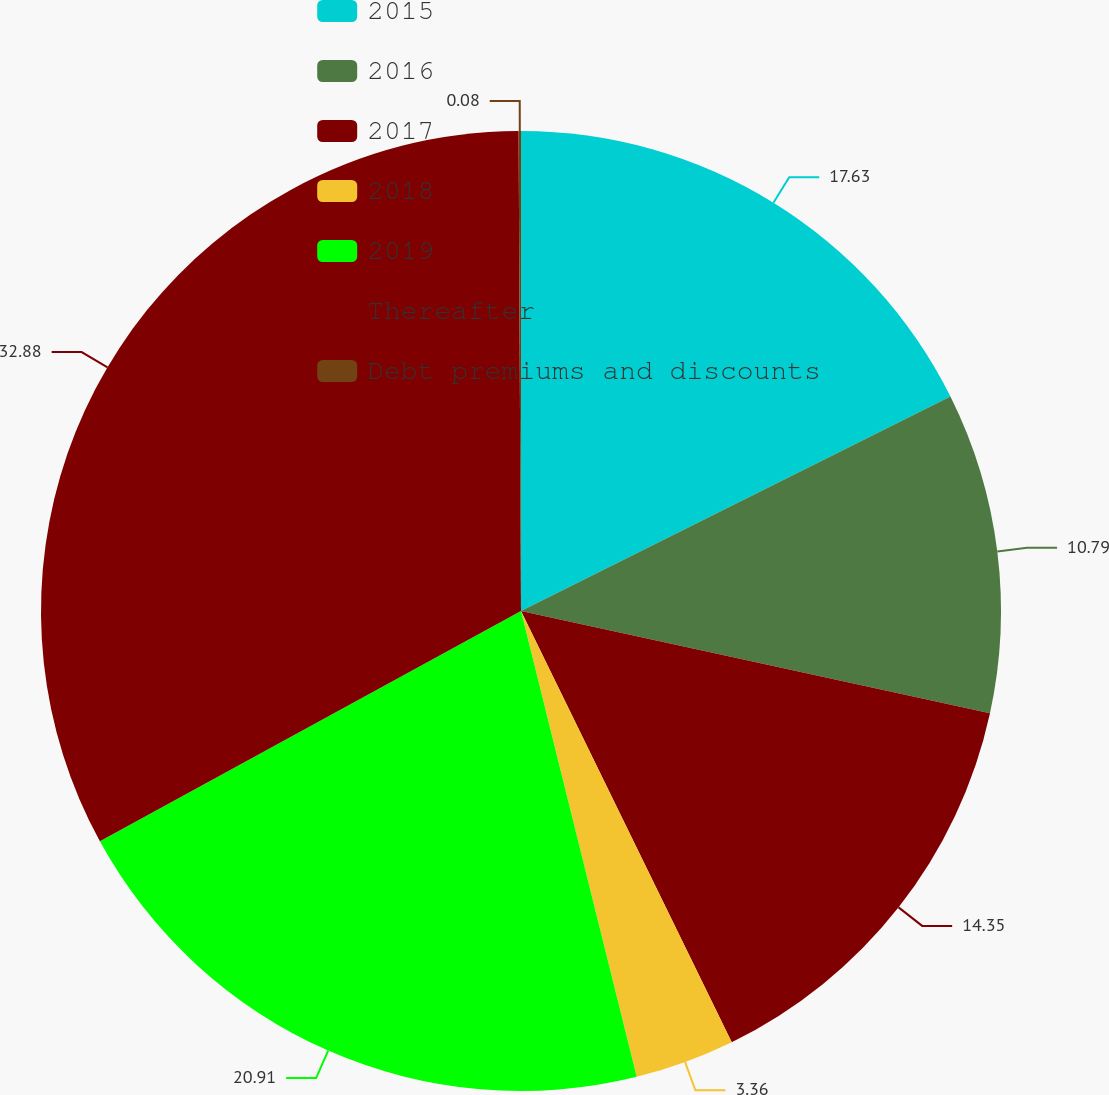Convert chart to OTSL. <chart><loc_0><loc_0><loc_500><loc_500><pie_chart><fcel>2015<fcel>2016<fcel>2017<fcel>2018<fcel>2019<fcel>Thereafter<fcel>Debt premiums and discounts<nl><fcel>17.63%<fcel>10.79%<fcel>14.35%<fcel>3.36%<fcel>20.91%<fcel>32.89%<fcel>0.08%<nl></chart> 